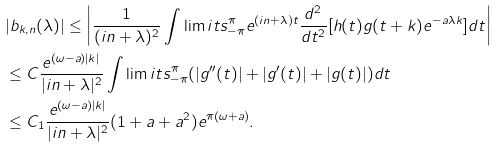<formula> <loc_0><loc_0><loc_500><loc_500>& | b _ { k , n } ( \lambda ) | \leq \left | \frac { 1 } { ( i n + \lambda ) ^ { 2 } } \int \lim i t s _ { - \pi } ^ { \pi } e ^ { ( i n + \lambda ) t } \frac { d ^ { 2 } } { d t ^ { 2 } } [ h ( t ) g ( t + k ) e ^ { - a \lambda k } ] d t \right | \\ & \leq C \frac { e ^ { ( \omega - a ) | k | } } { | i n + \lambda | ^ { 2 } } \int \lim i t s _ { - \pi } ^ { \pi } ( | g ^ { \prime \prime } ( t ) | + | g ^ { \prime } ( t ) | + | g ( t ) | ) d t \\ & \leq C _ { 1 } \frac { e ^ { ( \omega - a ) | k | } } { | i n + \lambda | ^ { 2 } } ( 1 + a + a ^ { 2 } ) e ^ { \pi ( \omega + a ) } .</formula> 